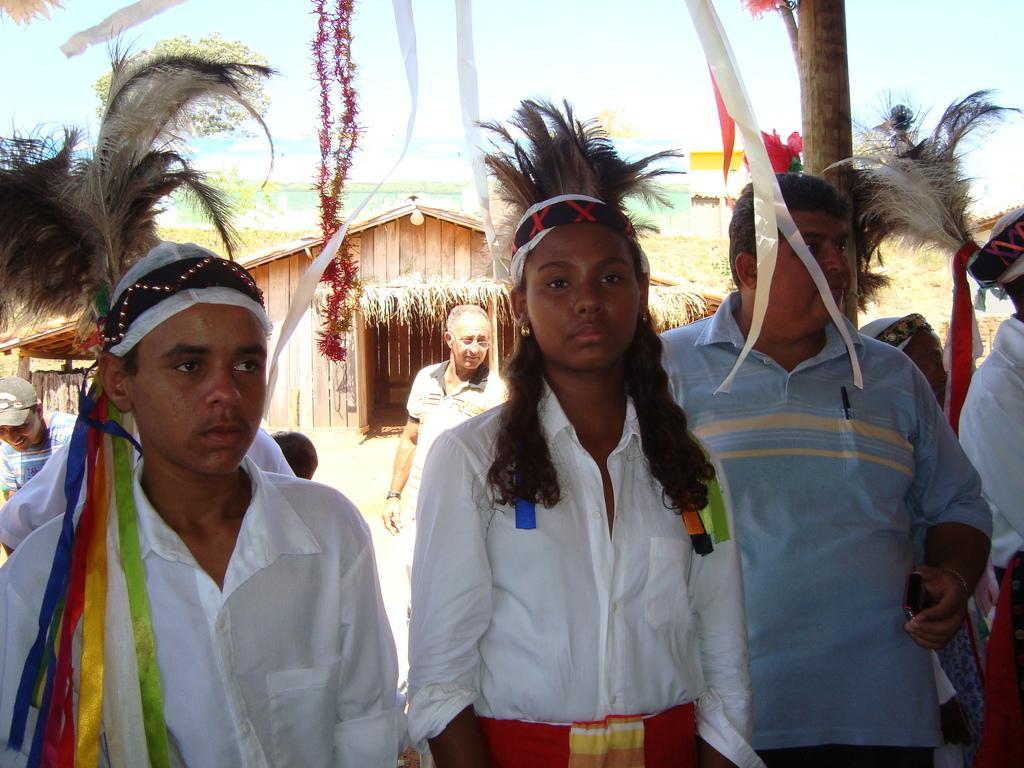Please provide a concise description of this image. Here we can see few persons. In the background there is a hut. 